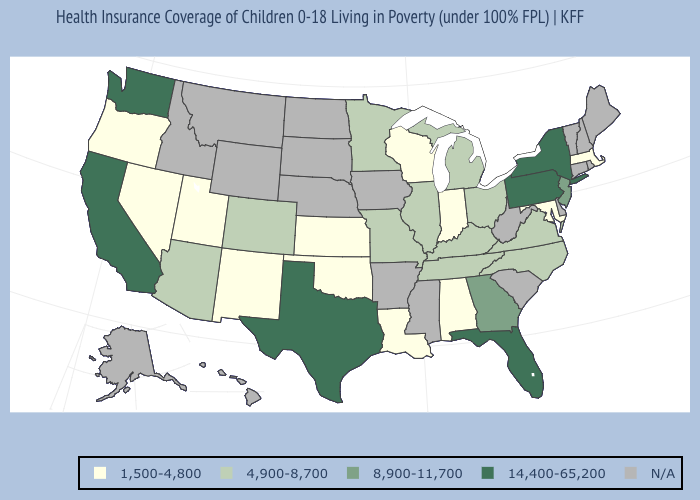Name the states that have a value in the range 4,900-8,700?
Concise answer only. Arizona, Colorado, Illinois, Kentucky, Michigan, Minnesota, Missouri, North Carolina, Ohio, Tennessee, Virginia. What is the value of Tennessee?
Be succinct. 4,900-8,700. Does Wisconsin have the lowest value in the MidWest?
Quick response, please. Yes. Name the states that have a value in the range 14,400-65,200?
Be succinct. California, Florida, New York, Pennsylvania, Texas, Washington. Among the states that border New York , which have the lowest value?
Keep it brief. Massachusetts. What is the value of Vermont?
Short answer required. N/A. What is the value of Arizona?
Answer briefly. 4,900-8,700. What is the lowest value in the MidWest?
Quick response, please. 1,500-4,800. What is the lowest value in the USA?
Be succinct. 1,500-4,800. What is the highest value in the USA?
Write a very short answer. 14,400-65,200. Name the states that have a value in the range 1,500-4,800?
Write a very short answer. Alabama, Indiana, Kansas, Louisiana, Maryland, Massachusetts, Nevada, New Mexico, Oklahoma, Oregon, Utah, Wisconsin. What is the value of Tennessee?
Give a very brief answer. 4,900-8,700. Among the states that border West Virginia , does Kentucky have the lowest value?
Short answer required. No. 